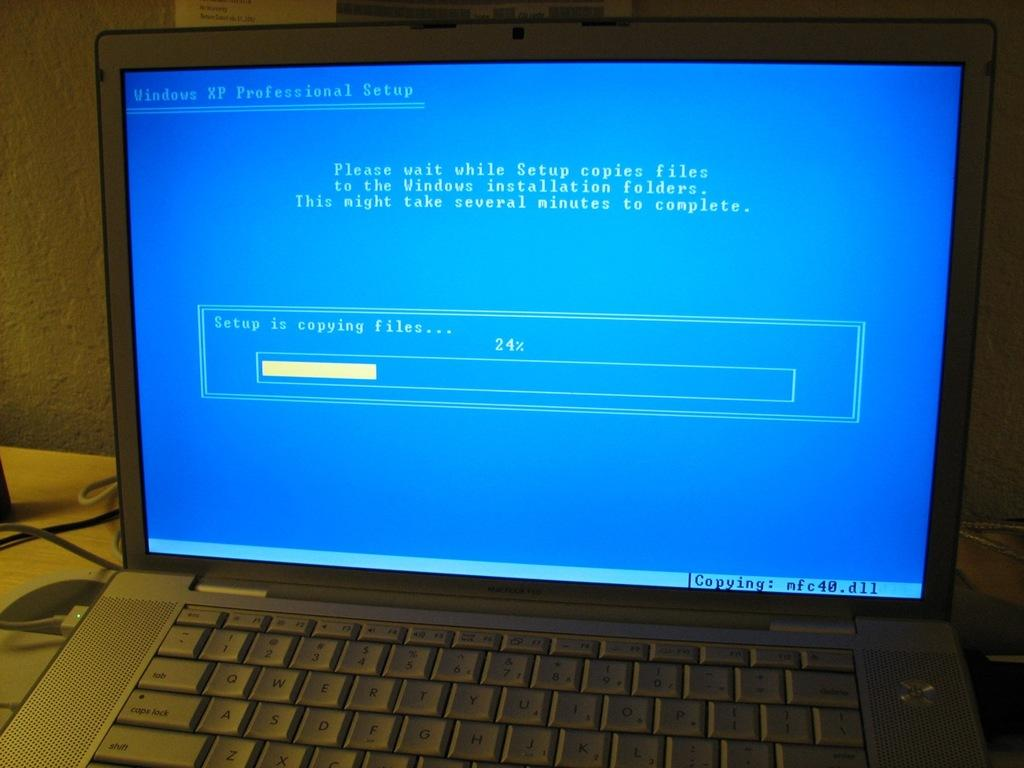Provide a one-sentence caption for the provided image. A monitor with Windows XP Professional setup at the top. 